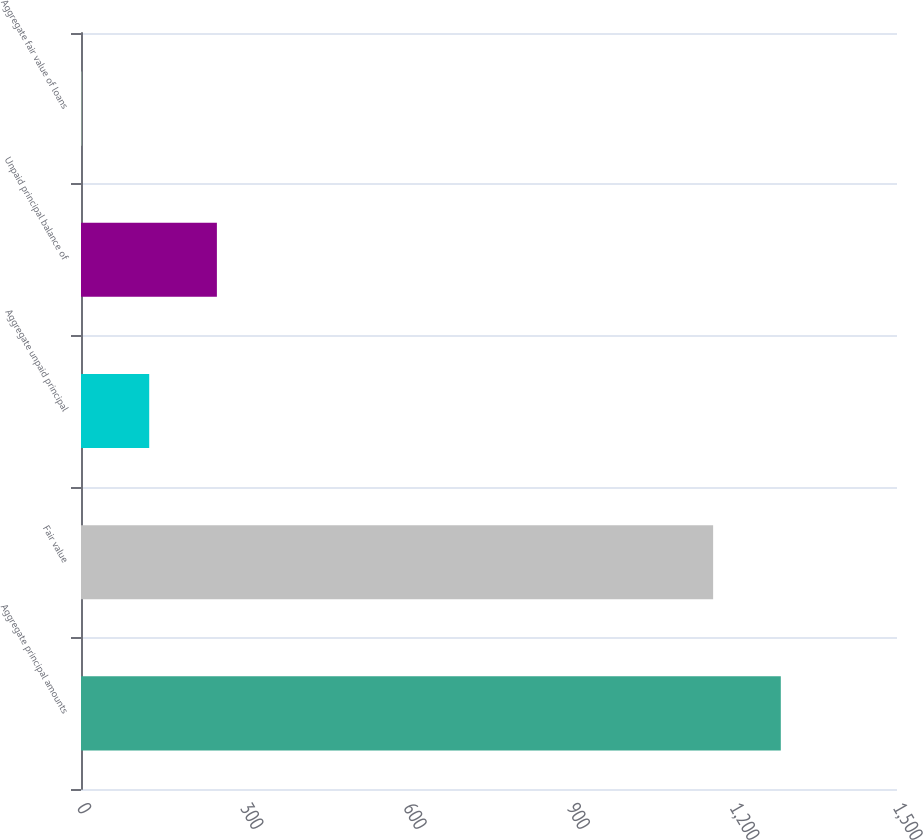Convert chart to OTSL. <chart><loc_0><loc_0><loc_500><loc_500><bar_chart><fcel>Aggregate principal amounts<fcel>Fair value<fcel>Aggregate unpaid principal<fcel>Unpaid principal balance of<fcel>Aggregate fair value of loans<nl><fcel>1286.4<fcel>1162<fcel>125.4<fcel>249.8<fcel>1<nl></chart> 